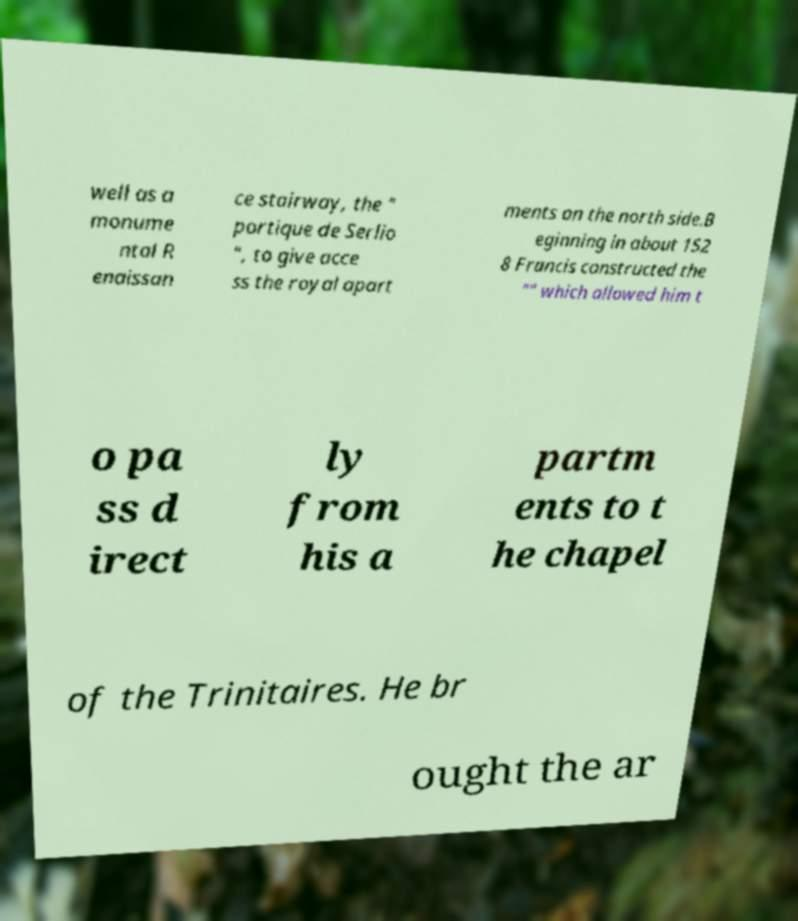What messages or text are displayed in this image? I need them in a readable, typed format. well as a monume ntal R enaissan ce stairway, the " portique de Serlio ", to give acce ss the royal apart ments on the north side.B eginning in about 152 8 Francis constructed the "" which allowed him t o pa ss d irect ly from his a partm ents to t he chapel of the Trinitaires. He br ought the ar 